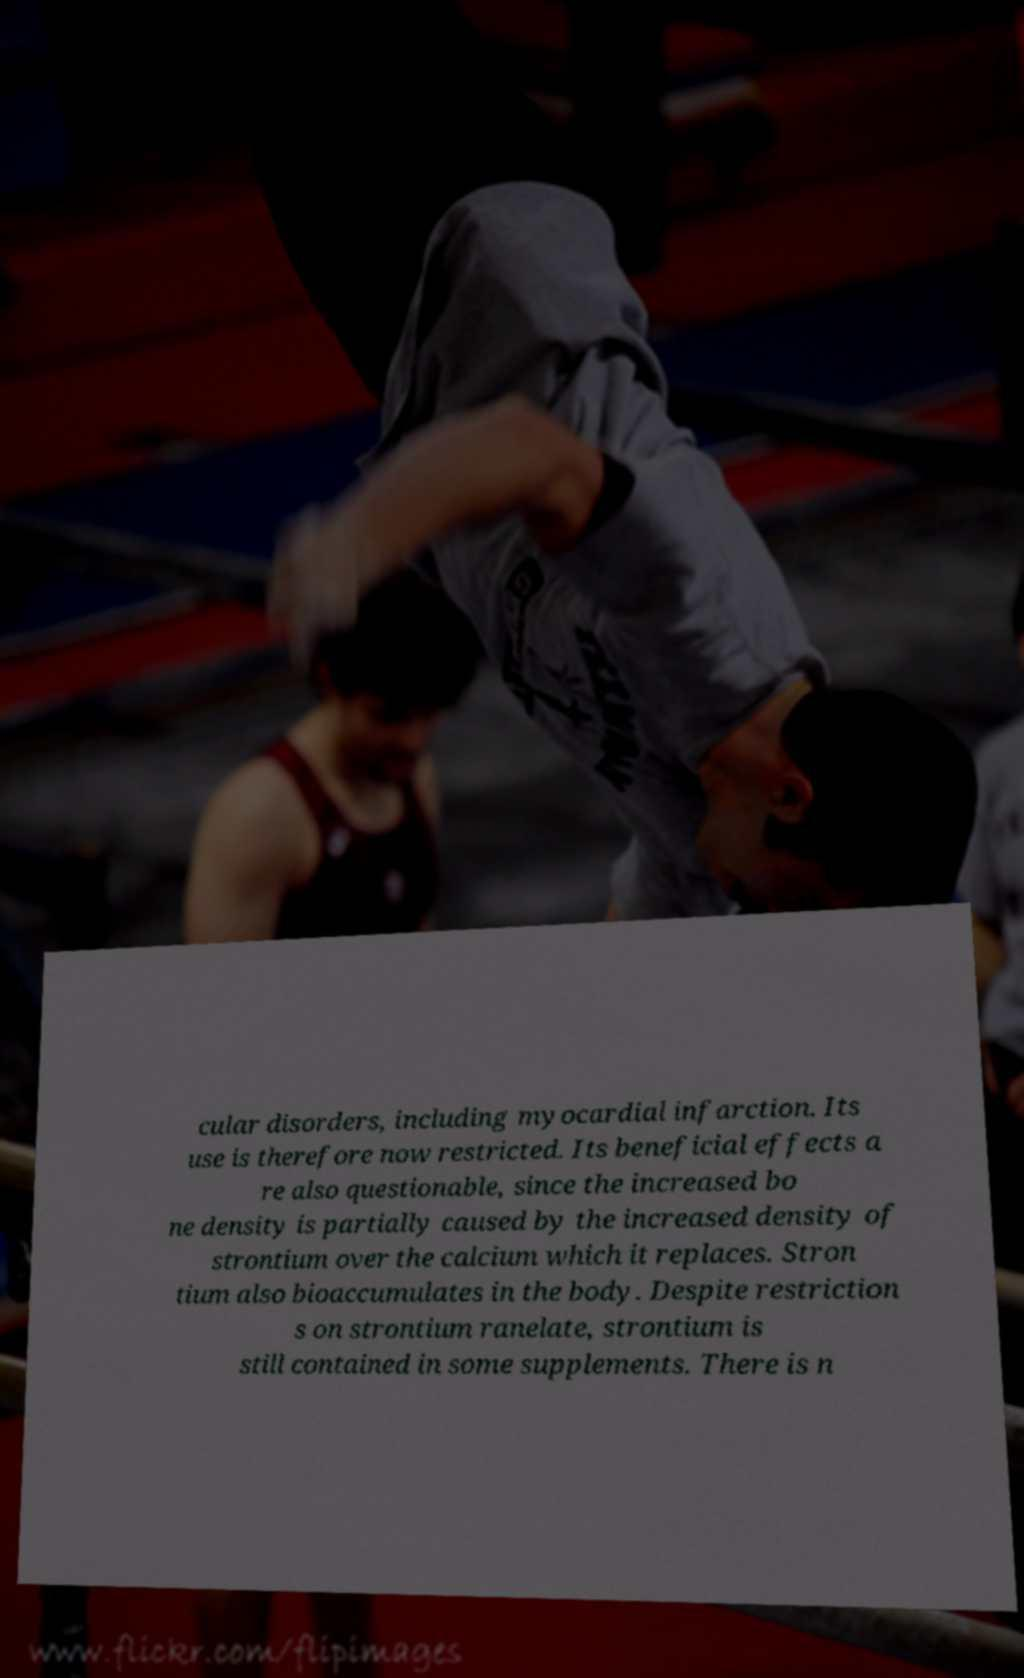Please identify and transcribe the text found in this image. cular disorders, including myocardial infarction. Its use is therefore now restricted. Its beneficial effects a re also questionable, since the increased bo ne density is partially caused by the increased density of strontium over the calcium which it replaces. Stron tium also bioaccumulates in the body. Despite restriction s on strontium ranelate, strontium is still contained in some supplements. There is n 